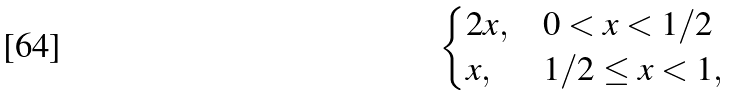<formula> <loc_0><loc_0><loc_500><loc_500>\begin{cases} 2 x , & 0 < x < 1 / 2 \\ x , & 1 / 2 \leq x < 1 , \end{cases}</formula> 